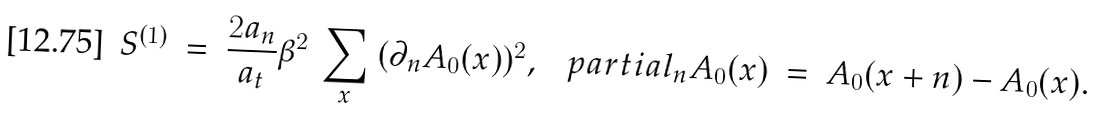<formula> <loc_0><loc_0><loc_500><loc_500>S ^ { ( 1 ) } \ = \ \frac { 2 a _ { n } } { a _ { t } } \beta ^ { 2 } \ \sum _ { x } \ ( \partial _ { n } A _ { 0 } ( x ) ) ^ { 2 } , \ \ \ p a r t i a l _ { n } A _ { 0 } ( x ) \ = \ A _ { 0 } ( x + n ) - A _ { 0 } ( x ) .</formula> 